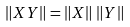<formula> <loc_0><loc_0><loc_500><loc_500>\left \| X Y \right \| = \left \| X \right \| \, \left \| Y \right \|</formula> 